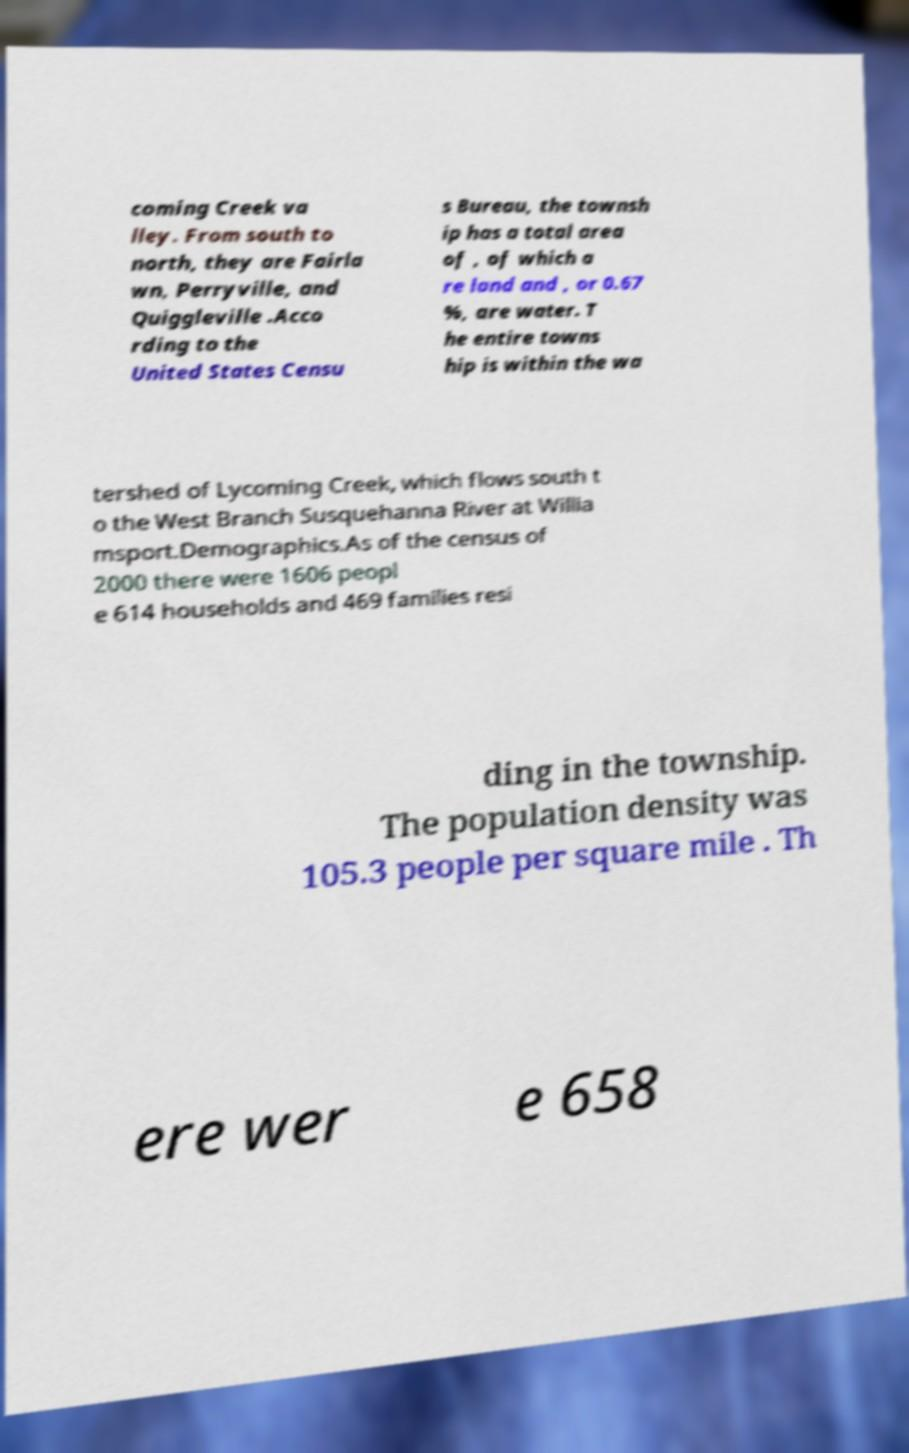Can you accurately transcribe the text from the provided image for me? coming Creek va lley. From south to north, they are Fairla wn, Perryville, and Quiggleville .Acco rding to the United States Censu s Bureau, the townsh ip has a total area of , of which a re land and , or 0.67 %, are water. T he entire towns hip is within the wa tershed of Lycoming Creek, which flows south t o the West Branch Susquehanna River at Willia msport.Demographics.As of the census of 2000 there were 1606 peopl e 614 households and 469 families resi ding in the township. The population density was 105.3 people per square mile . Th ere wer e 658 